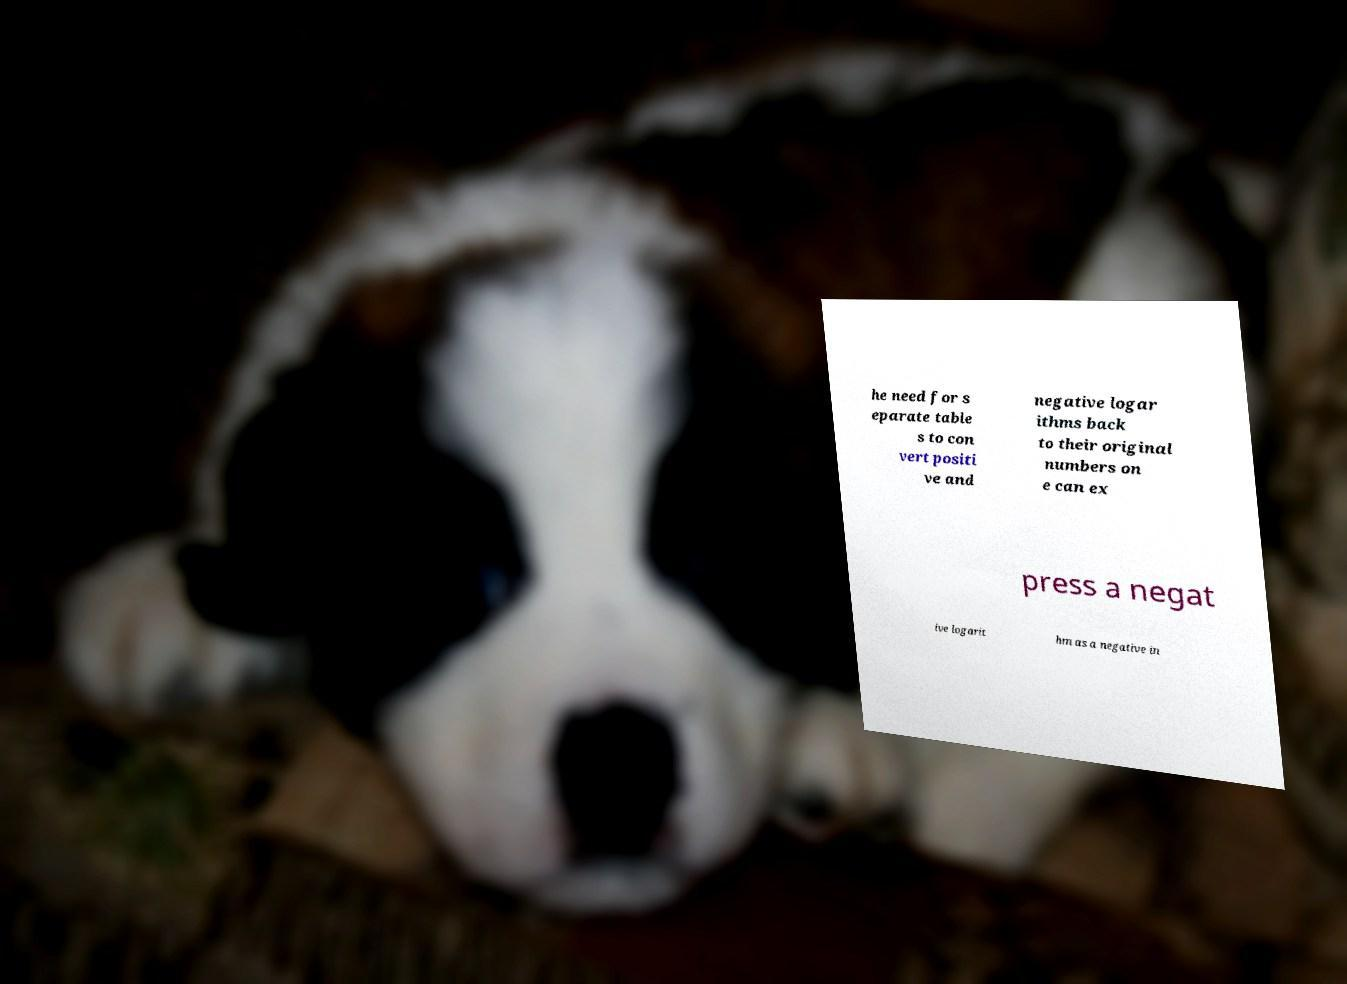What messages or text are displayed in this image? I need them in a readable, typed format. he need for s eparate table s to con vert positi ve and negative logar ithms back to their original numbers on e can ex press a negat ive logarit hm as a negative in 